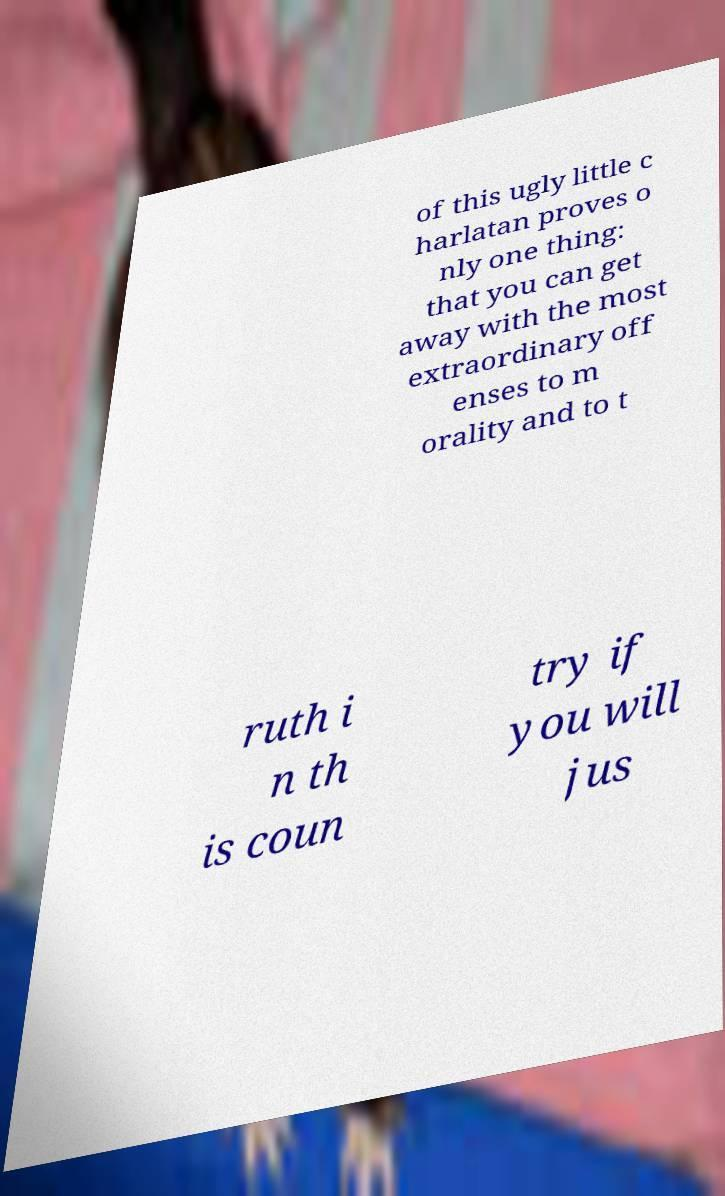What messages or text are displayed in this image? I need them in a readable, typed format. of this ugly little c harlatan proves o nly one thing: that you can get away with the most extraordinary off enses to m orality and to t ruth i n th is coun try if you will jus 